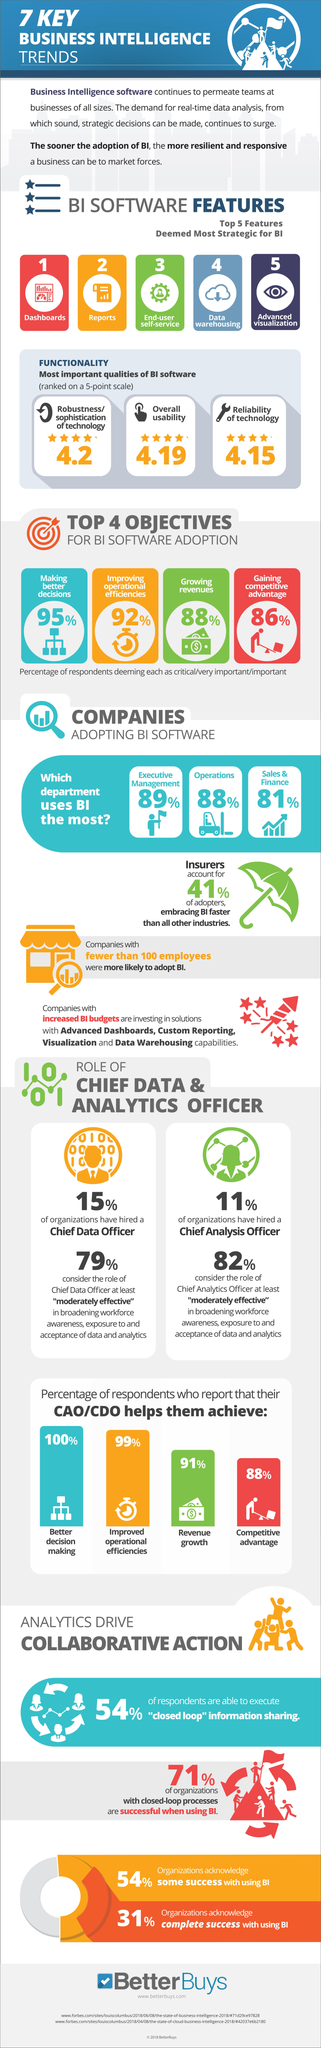Indicate a few pertinent items in this graphic. According to the results of the survey, a staggering 88% of respondents believe that adopting BI software is very critical in growing revenues. According to the survey, 95% of respondents believe that adopting BI software is very critical in making better decisions. According to a study, 81% of sales and finance companies use Business Intelligence (BI) software. The overall usability of BI software is ranked on a 5-point scale, with a rating of 4.19. The overall reliability of BI software is ranked on a 5-point scale and has been given a score of 4.15. 